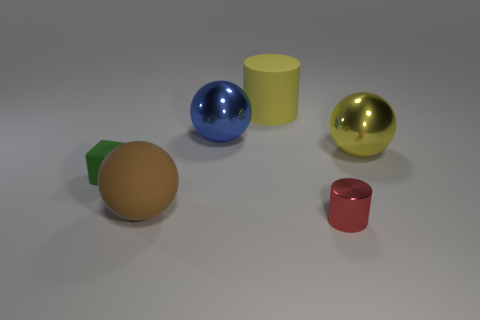How do the textures of the various objects compare? The objects in the image exhibit a variety of textures. The blue and golden spheres have a glossy, reflective surface indicating a smooth texture, possibly metallic or glass-like. The large brown sphere has a uniform, matte texture suggesting it could be made of clay or a similar material. The green truncated object paired with the brown sphere has a slightly glossy finish, while both cylindrical objects have matte finishes with the yellow one having a more pronounced texture than the red one. 